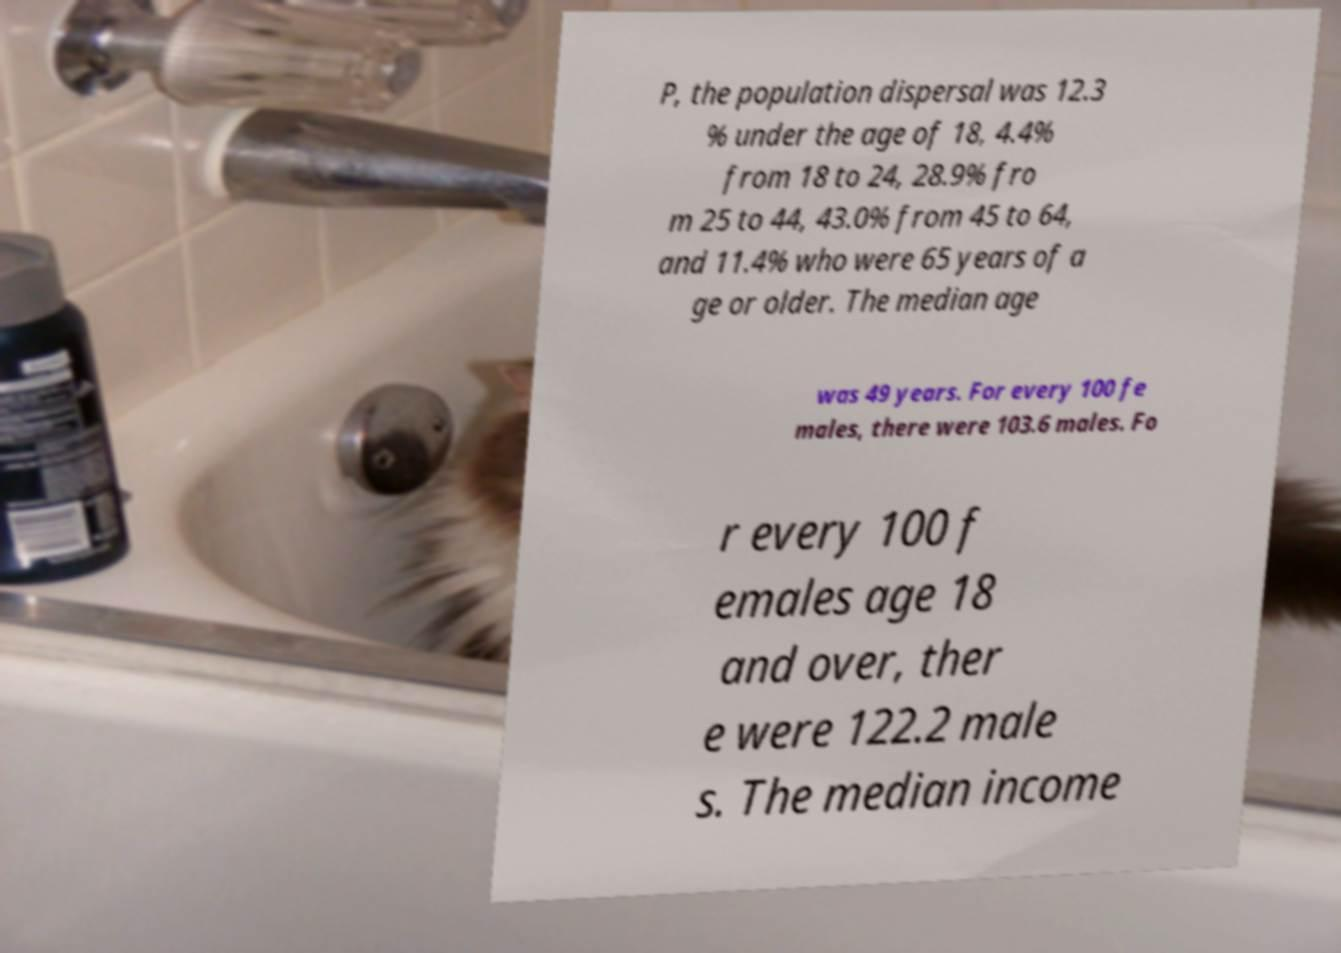Please read and relay the text visible in this image. What does it say? P, the population dispersal was 12.3 % under the age of 18, 4.4% from 18 to 24, 28.9% fro m 25 to 44, 43.0% from 45 to 64, and 11.4% who were 65 years of a ge or older. The median age was 49 years. For every 100 fe males, there were 103.6 males. Fo r every 100 f emales age 18 and over, ther e were 122.2 male s. The median income 